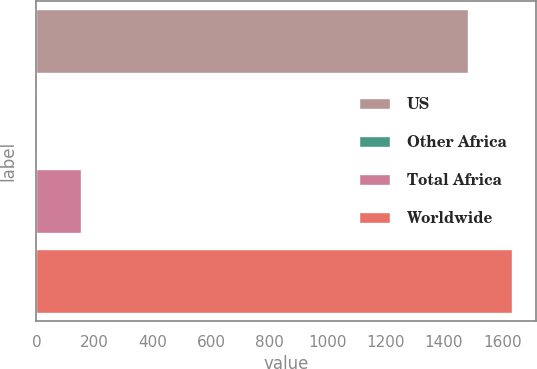<chart> <loc_0><loc_0><loc_500><loc_500><bar_chart><fcel>US<fcel>Other Africa<fcel>Total Africa<fcel>Worldwide<nl><fcel>1482<fcel>1<fcel>151.9<fcel>1632.9<nl></chart> 